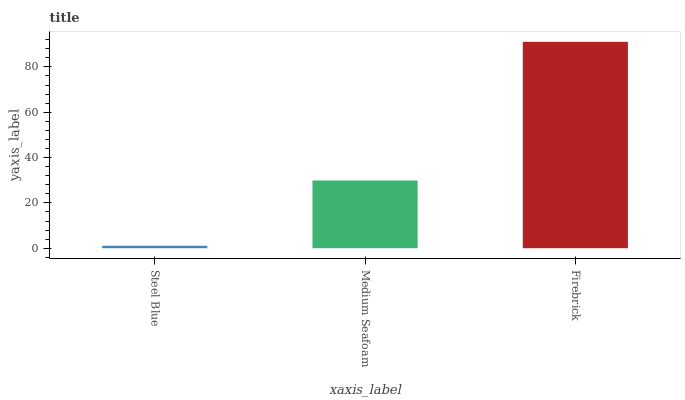Is Steel Blue the minimum?
Answer yes or no. Yes. Is Firebrick the maximum?
Answer yes or no. Yes. Is Medium Seafoam the minimum?
Answer yes or no. No. Is Medium Seafoam the maximum?
Answer yes or no. No. Is Medium Seafoam greater than Steel Blue?
Answer yes or no. Yes. Is Steel Blue less than Medium Seafoam?
Answer yes or no. Yes. Is Steel Blue greater than Medium Seafoam?
Answer yes or no. No. Is Medium Seafoam less than Steel Blue?
Answer yes or no. No. Is Medium Seafoam the high median?
Answer yes or no. Yes. Is Medium Seafoam the low median?
Answer yes or no. Yes. Is Steel Blue the high median?
Answer yes or no. No. Is Firebrick the low median?
Answer yes or no. No. 